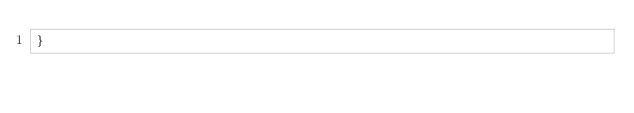<code> <loc_0><loc_0><loc_500><loc_500><_TypeScript_>}
</code> 